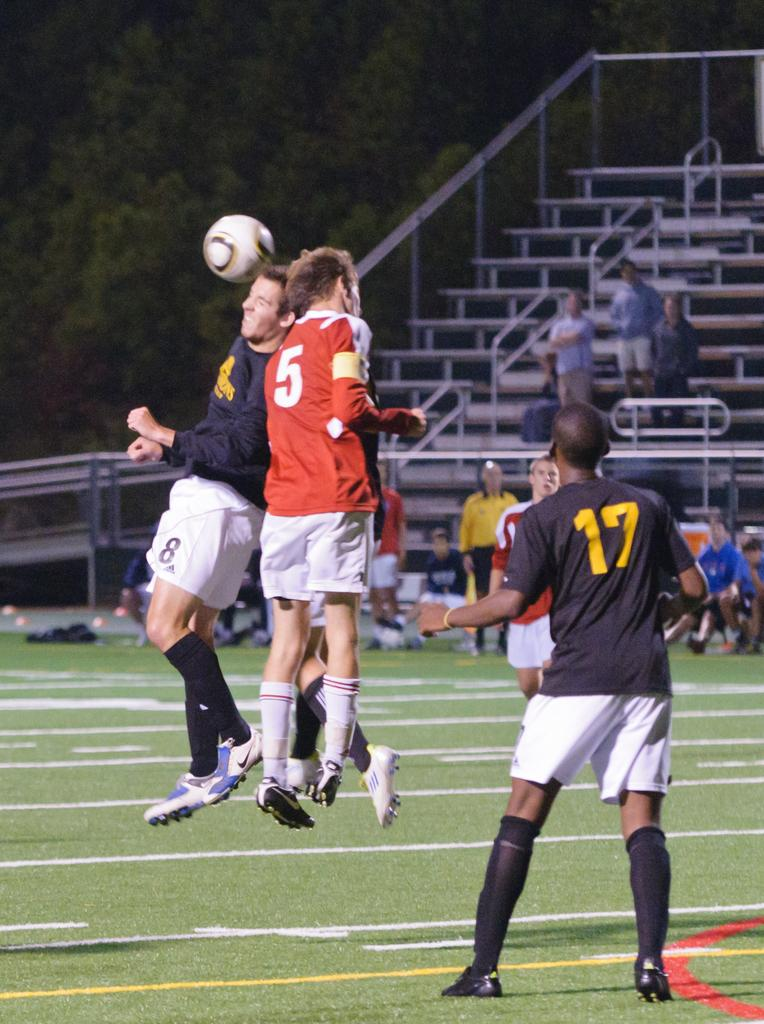Provide a one-sentence caption for the provided image. A soccer game where player 8 from the blue team and player 5 from the red team both try to head butt the ball. 